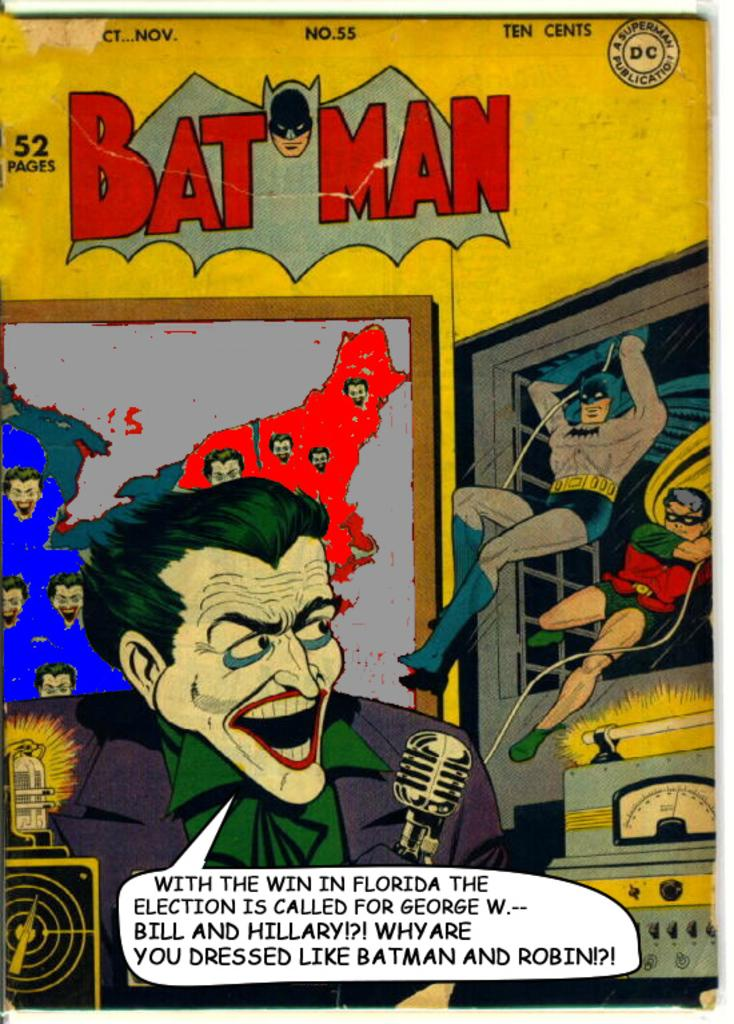What type of visual is the image? The image is a poster. Who or what can be seen on the poster? There are people depicted on the poster. What objects are associated with the people on the poster? There are microphones (mics) on the poster. What other objects are present on the poster? There are boards and other objects on the poster. Is there any text on the poster? Yes, there is text on the poster. Is there any branding or identification on the poster? Yes, there is a logo on the poster. Can you see any animals from the zoo in the poster? There are no animals from the zoo depicted in the poster. Is there a guitar being played by any of the people on the poster? There is no guitar present in the poster. 